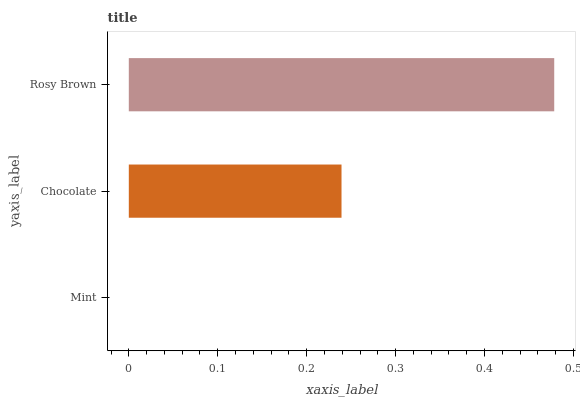Is Mint the minimum?
Answer yes or no. Yes. Is Rosy Brown the maximum?
Answer yes or no. Yes. Is Chocolate the minimum?
Answer yes or no. No. Is Chocolate the maximum?
Answer yes or no. No. Is Chocolate greater than Mint?
Answer yes or no. Yes. Is Mint less than Chocolate?
Answer yes or no. Yes. Is Mint greater than Chocolate?
Answer yes or no. No. Is Chocolate less than Mint?
Answer yes or no. No. Is Chocolate the high median?
Answer yes or no. Yes. Is Chocolate the low median?
Answer yes or no. Yes. Is Mint the high median?
Answer yes or no. No. Is Rosy Brown the low median?
Answer yes or no. No. 